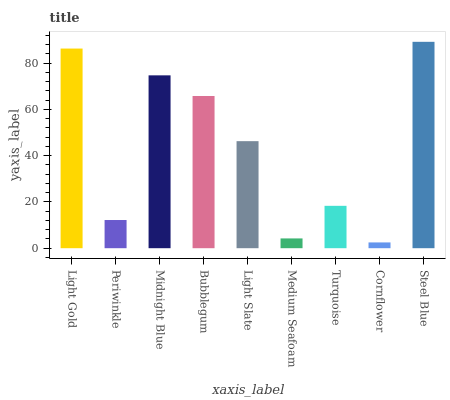Is Cornflower the minimum?
Answer yes or no. Yes. Is Steel Blue the maximum?
Answer yes or no. Yes. Is Periwinkle the minimum?
Answer yes or no. No. Is Periwinkle the maximum?
Answer yes or no. No. Is Light Gold greater than Periwinkle?
Answer yes or no. Yes. Is Periwinkle less than Light Gold?
Answer yes or no. Yes. Is Periwinkle greater than Light Gold?
Answer yes or no. No. Is Light Gold less than Periwinkle?
Answer yes or no. No. Is Light Slate the high median?
Answer yes or no. Yes. Is Light Slate the low median?
Answer yes or no. Yes. Is Light Gold the high median?
Answer yes or no. No. Is Periwinkle the low median?
Answer yes or no. No. 